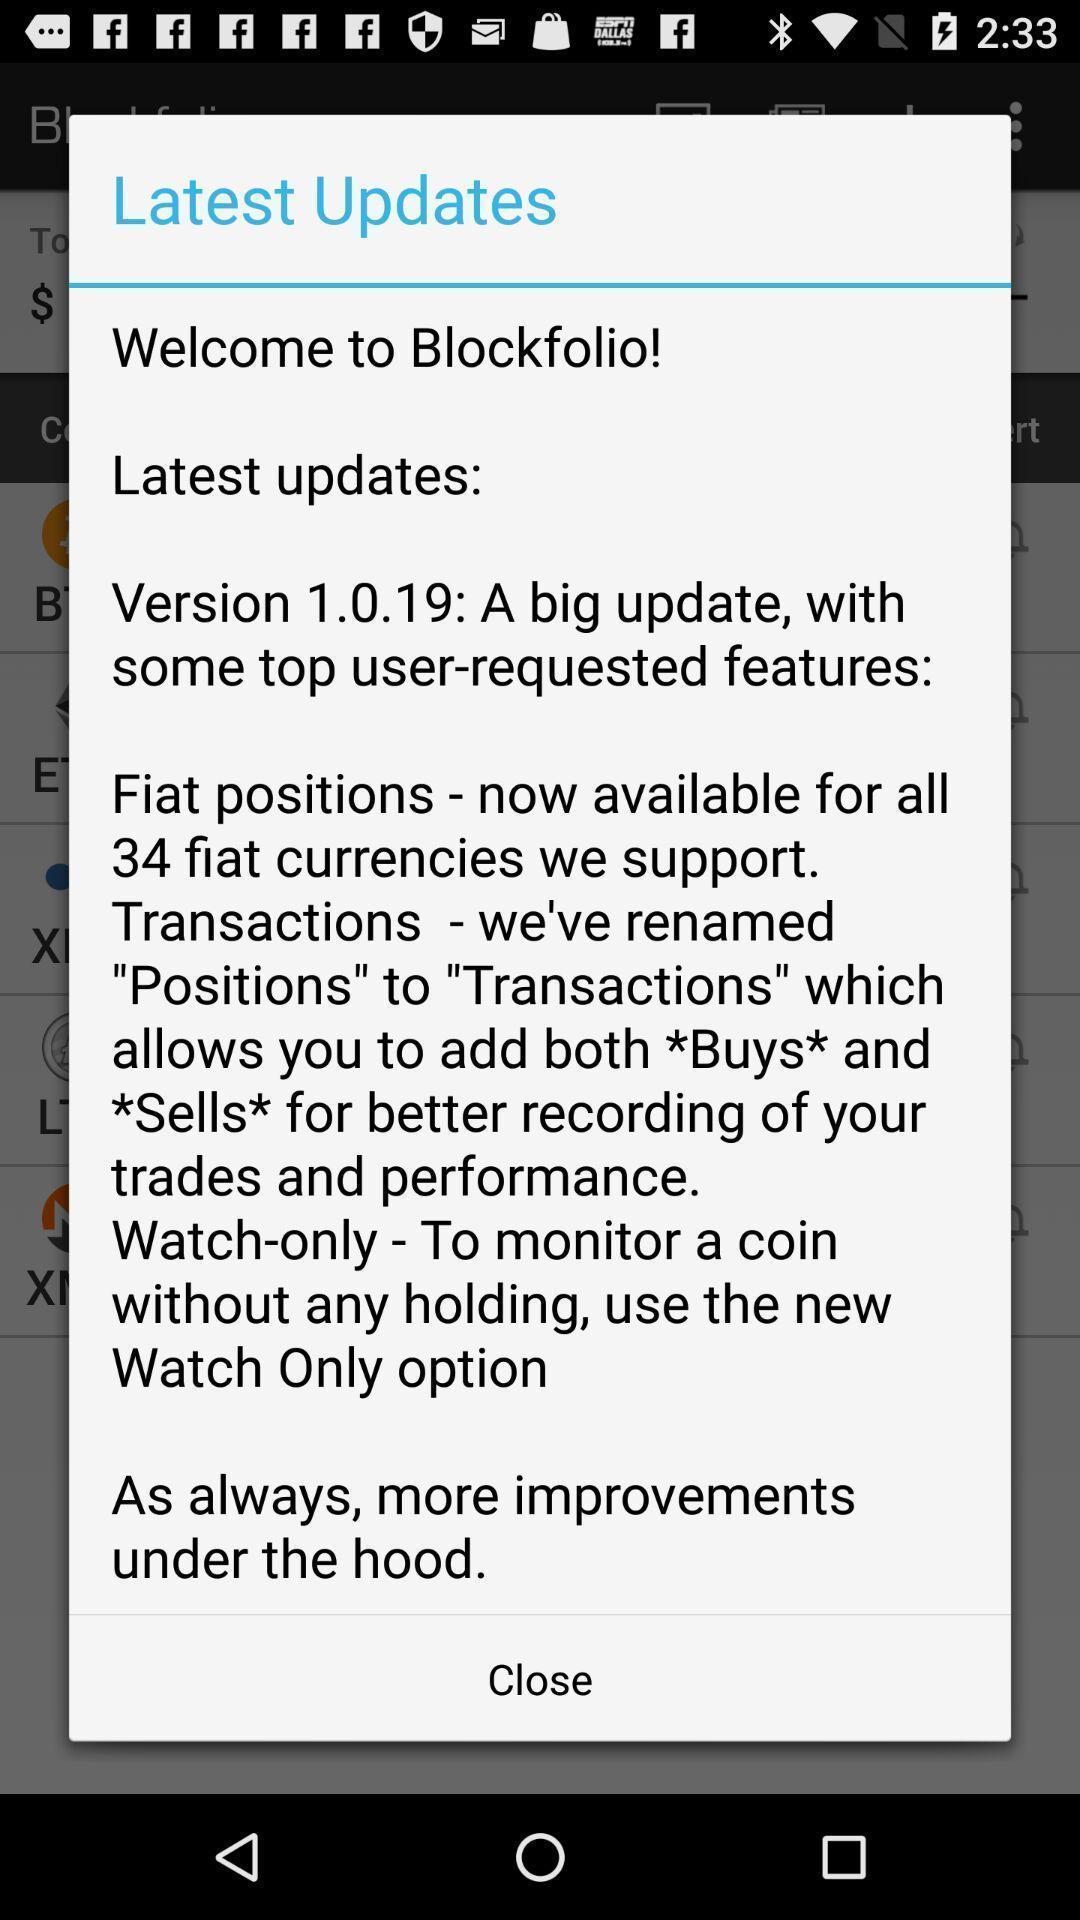Provide a textual representation of this image. Pop-up displaying information about updates. 